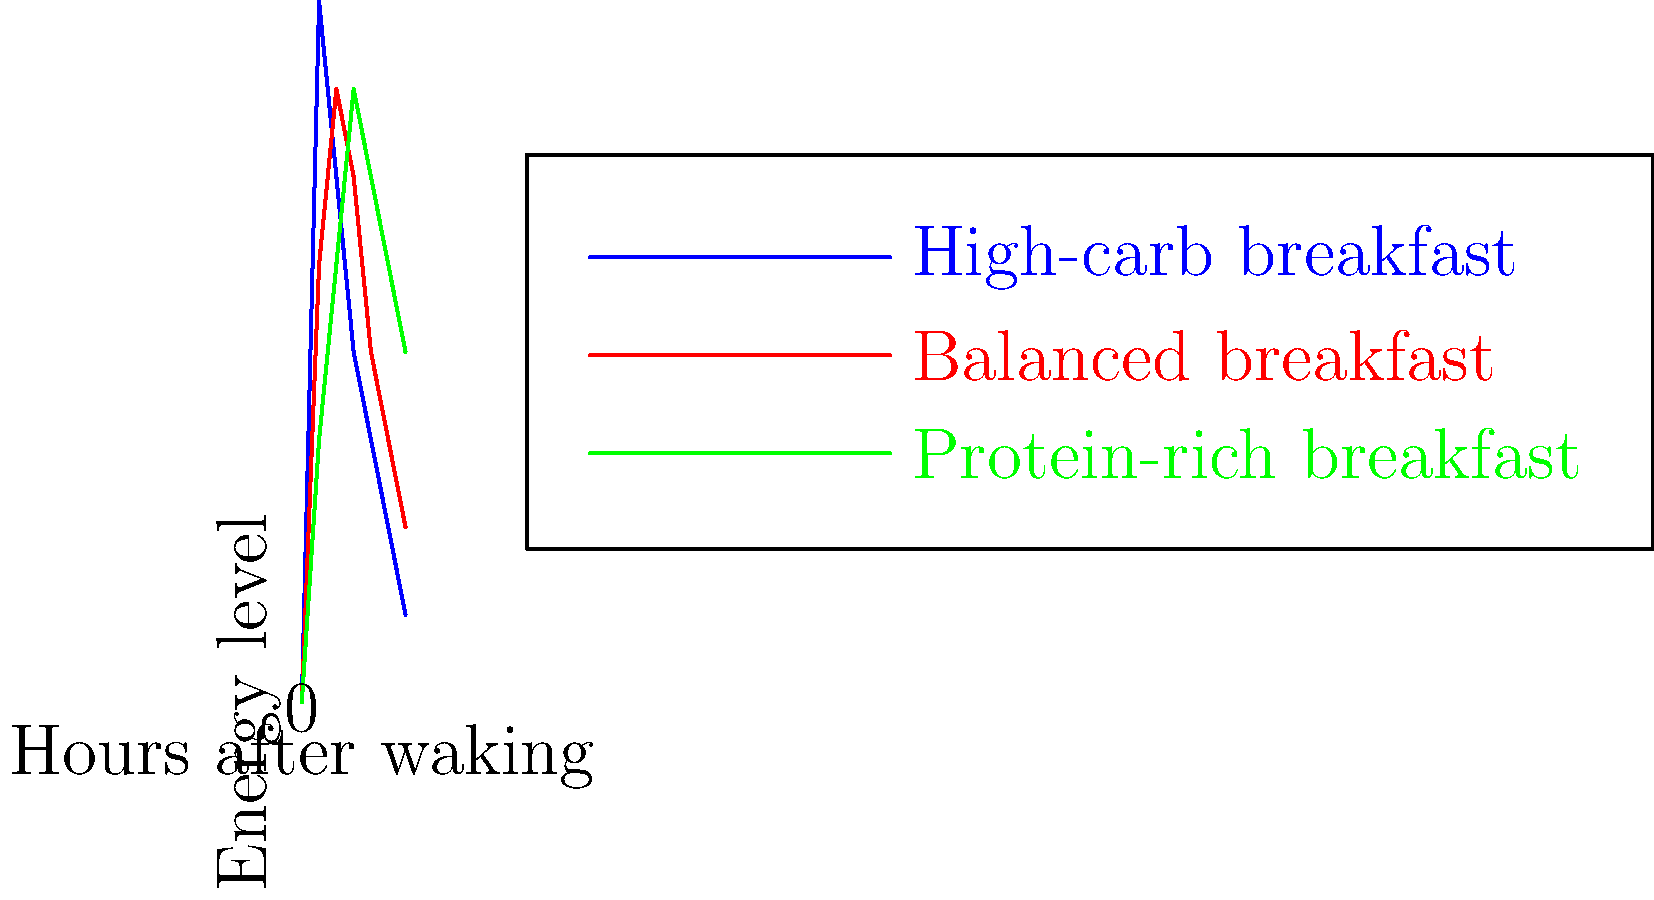Based on the line graph showing energy levels throughout the day for different breakfast choices, which breakfast option would be most suitable for maintaining consistent energy levels without spending too much time on preparation? To answer this question, we need to analyze the energy level patterns for each breakfast option:

1. High-carb breakfast (blue line):
   - Provides a quick energy boost (highest peak at 2 hours)
   - Energy levels decline rapidly after the initial spike
   - Ends with the lowest energy level at 12 hours

2. Balanced breakfast (red line):
   - Moderate initial energy boost
   - More stable energy levels throughout the day
   - Ends with a medium energy level at 12 hours

3. Protein-rich breakfast (green line):
   - Slowest initial energy boost
   - Energy levels increase gradually and remain higher for longer
   - Ends with the highest energy level at 12 hours

Considering the persona of a health-conscious person who dislikes spending too much time on breakfast and hates mornings:

1. The high-carb breakfast is quick to prepare but leads to energy crashes, which is not ideal for maintaining consistent energy levels.
2. The balanced breakfast offers a good compromise between preparation time and energy stability, but may require more effort than desired.
3. The protein-rich breakfast provides the most consistent energy levels throughout the day. Many protein-rich breakfast options (e.g., Greek yogurt, hard-boiled eggs, or protein shakes) can be prepared quickly or in advance, making them suitable for someone who dislikes spending time on breakfast in the morning.

Given these factors, the protein-rich breakfast (green line) would be the most suitable option for maintaining consistent energy levels without spending too much time on preparation.
Answer: Protein-rich breakfast 